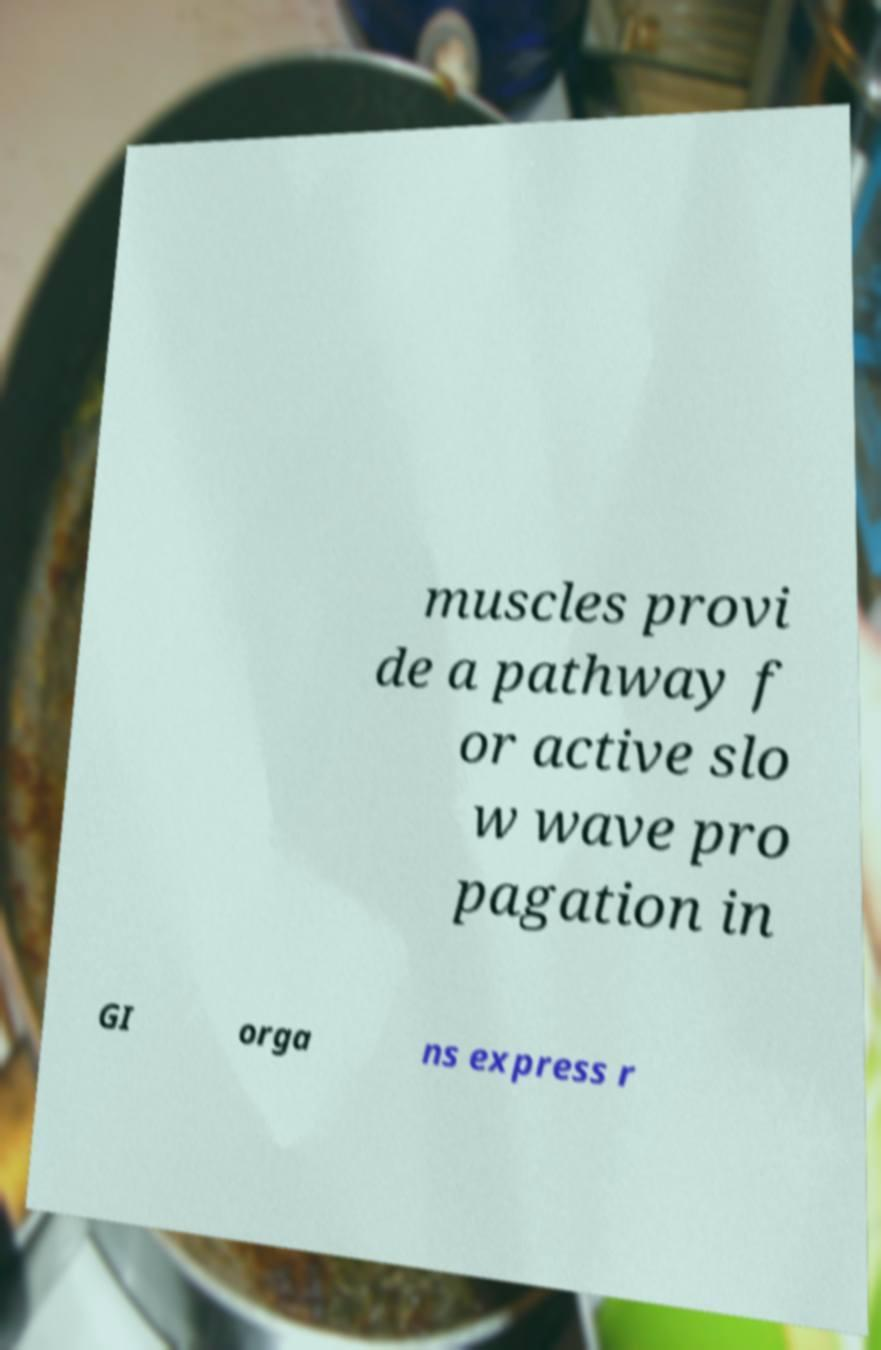Please identify and transcribe the text found in this image. muscles provi de a pathway f or active slo w wave pro pagation in GI orga ns express r 